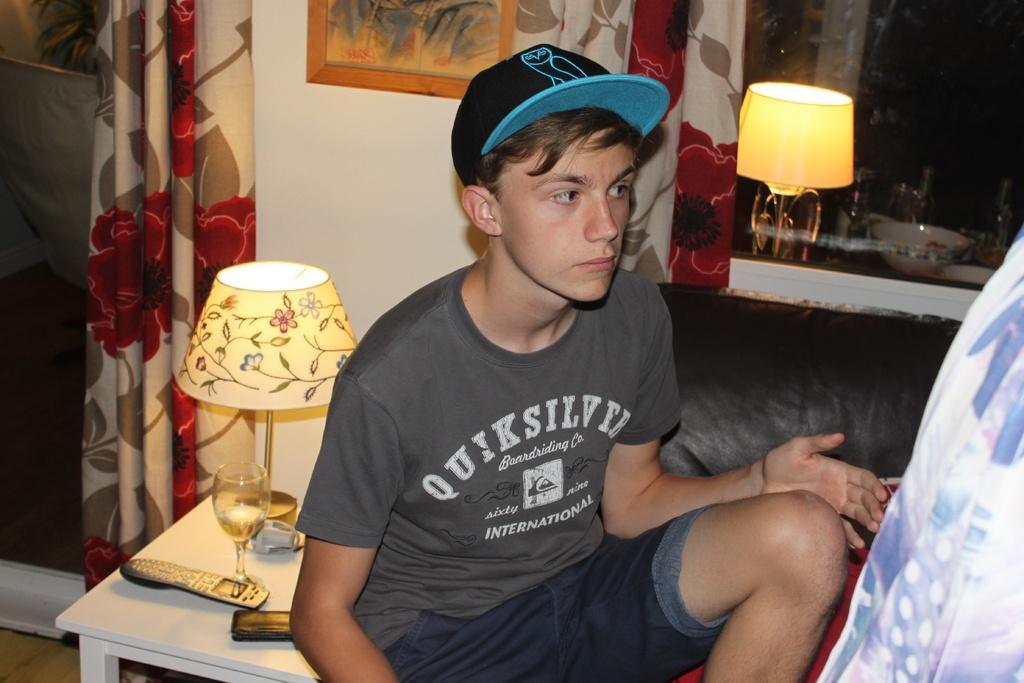How would you summarize this image in a sentence or two? In this image in the center there is a boy sitting and wearing a cap which is black and blue in colour. In the background there are curtains and there is a wall and on the wall there is a frame. In front of the wall there is a table and on the table there is a remote, glass and a lamp. On the right side there is a cloth. On the left side there is a glass and behind the glass there is a plant in the pot. 